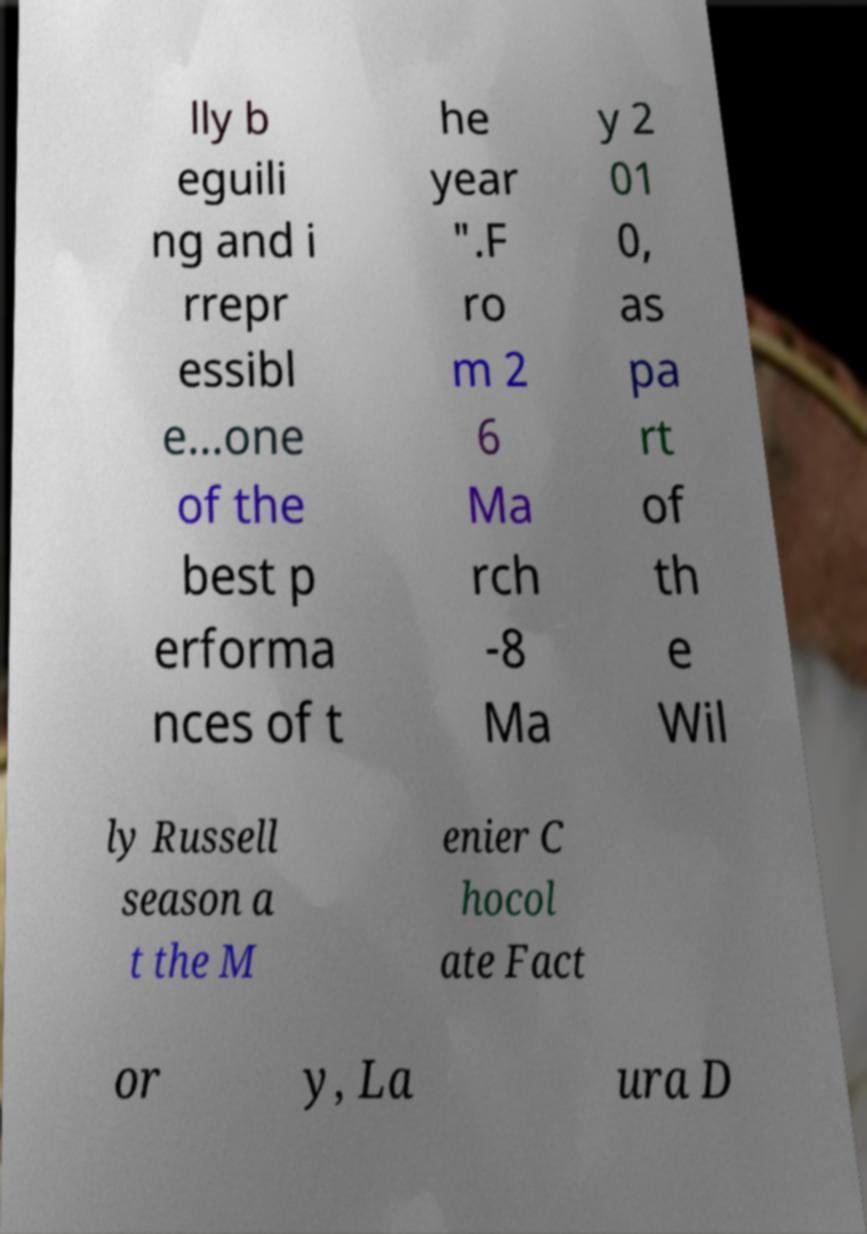Can you read and provide the text displayed in the image?This photo seems to have some interesting text. Can you extract and type it out for me? lly b eguili ng and i rrepr essibl e...one of the best p erforma nces of t he year ".F ro m 2 6 Ma rch -8 Ma y 2 01 0, as pa rt of th e Wil ly Russell season a t the M enier C hocol ate Fact or y, La ura D 